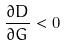Convert formula to latex. <formula><loc_0><loc_0><loc_500><loc_500>\frac { \partial D } { \partial G } < 0</formula> 